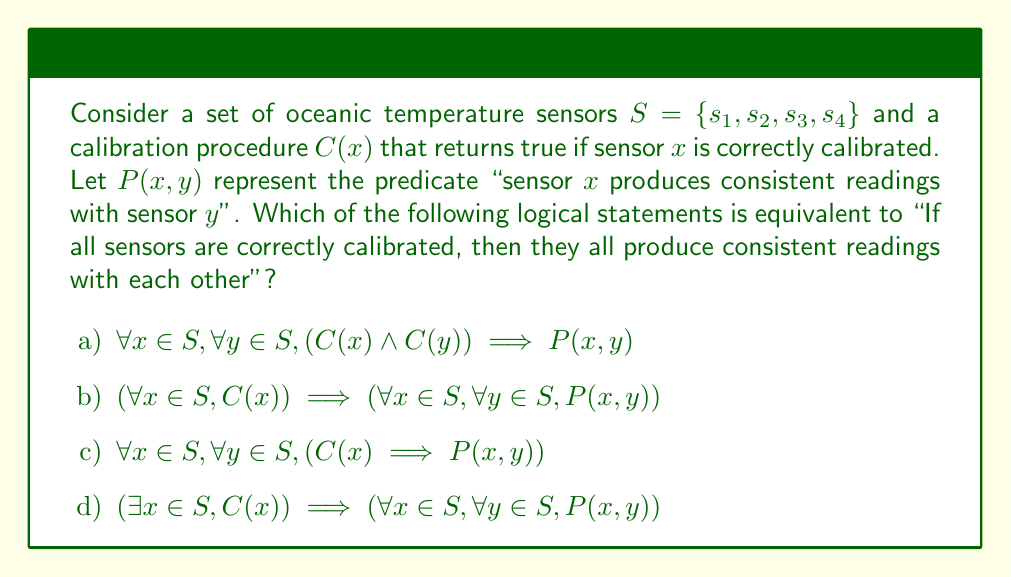Solve this math problem. To solve this problem, we need to understand the logical statement "If all sensors are correctly calibrated, then they all produce consistent readings with each other" and evaluate each option using predicate logic.

Let's break down the original statement:
1. Antecedent: "All sensors are correctly calibrated"
2. Consequent: "They all produce consistent readings with each other"

Now, let's analyze each option:

a) $\forall x \in S, \forall y \in S, (C(x) \land C(y)) \implies P(x, y)$
This statement says that for any two sensors, if both are calibrated, then they produce consistent readings. While this is true, it doesn't fully capture the original statement because it doesn't consider all sensors being calibrated at once.

b) $(\forall x \in S, C(x)) \implies (\forall x \in S, \forall y \in S, P(x, y))$
This statement correctly represents the original statement:
- $(\forall x \in S, C(x))$ means "all sensors are correctly calibrated"
- $(\forall x \in S, \forall y \in S, P(x, y))$ means "all sensors produce consistent readings with each other"
- The implication $\implies$ connects these two parts, matching the "if-then" structure of the original statement.

c) $\forall x \in S, \forall y \in S, (C(x) \implies P(x, y))$
This statement says that for any sensor $x$, if it is calibrated, then it produces consistent readings with all other sensors $y$. This is not equivalent to the original statement because it doesn't require all sensors to be calibrated simultaneously.

d) $(\exists x \in S, C(x)) \implies (\forall x \in S, \forall y \in S, P(x, y))$
This statement says that if there exists at least one calibrated sensor, then all sensors produce consistent readings with each other. This is clearly not equivalent to the original statement, as it only requires one sensor to be calibrated instead of all sensors.

Therefore, option b) is the correct logical representation of the given statement.
Answer: b) $(\forall x \in S, C(x)) \implies (\forall x \in S, \forall y \in S, P(x, y))$ 